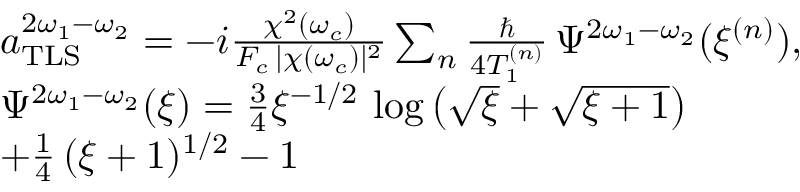<formula> <loc_0><loc_0><loc_500><loc_500>\begin{array} { r l } & { a _ { T L S } ^ { 2 \omega _ { 1 } - \omega _ { 2 } } = - i \frac { \chi ^ { 2 } ( \omega _ { c } ) } { F _ { c } \, | \chi ( \omega _ { c } ) | ^ { 2 } } \sum _ { n } \frac { } { 4 T _ { 1 } ^ { ( n ) } } \, \Psi ^ { 2 \omega _ { 1 } - \omega _ { 2 } } ( \xi ^ { ( n ) } ) , } \\ & { \Psi ^ { 2 \omega _ { 1 } - \omega _ { 2 } } ( \xi ) = \frac { 3 } { 4 } \xi ^ { - 1 / 2 } \, \log \left ( \sqrt { \xi } + \sqrt { \xi + 1 } \right ) } \\ & { + \frac { 1 } { 4 } \, ( \xi + 1 ) ^ { 1 / 2 } - 1 } \end{array}</formula> 